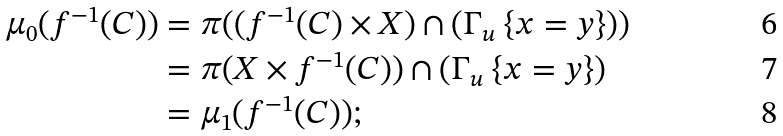Convert formula to latex. <formula><loc_0><loc_0><loc_500><loc_500>\mu _ { 0 } ( f ^ { - 1 } ( C ) ) & = \pi ( ( f ^ { - 1 } ( C ) \times X ) \cap ( \Gamma _ { u } \ \{ x = y \} ) ) \\ & = \pi ( X \times f ^ { - 1 } ( C ) ) \cap ( \Gamma _ { u } \ \{ x = y \} ) \\ & = \mu _ { 1 } ( f ^ { - 1 } ( C ) ) ;</formula> 